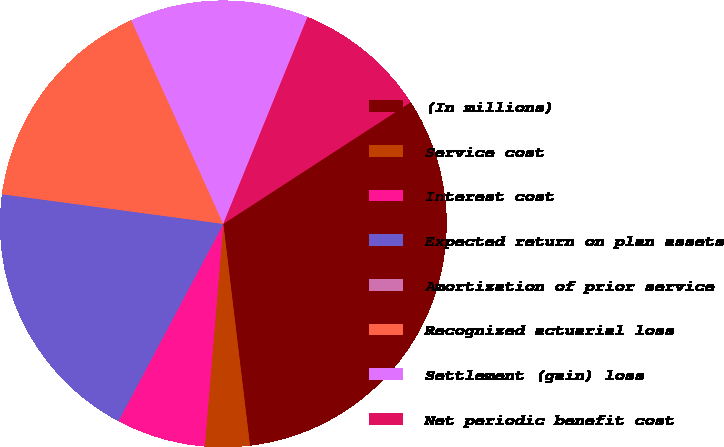Convert chart to OTSL. <chart><loc_0><loc_0><loc_500><loc_500><pie_chart><fcel>(In millions)<fcel>Service cost<fcel>Interest cost<fcel>Expected return on plan assets<fcel>Amortization of prior service<fcel>Recognized actuarial loss<fcel>Settlement (gain) loss<fcel>Net periodic benefit cost<nl><fcel>32.26%<fcel>3.23%<fcel>6.45%<fcel>19.35%<fcel>0.0%<fcel>16.13%<fcel>12.9%<fcel>9.68%<nl></chart> 